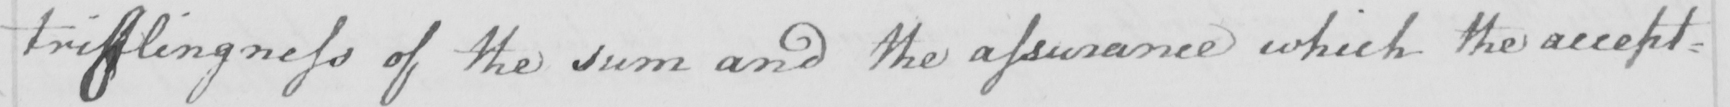Transcribe the text shown in this historical manuscript line. triflingness of the sum and the assurance which the accept= 